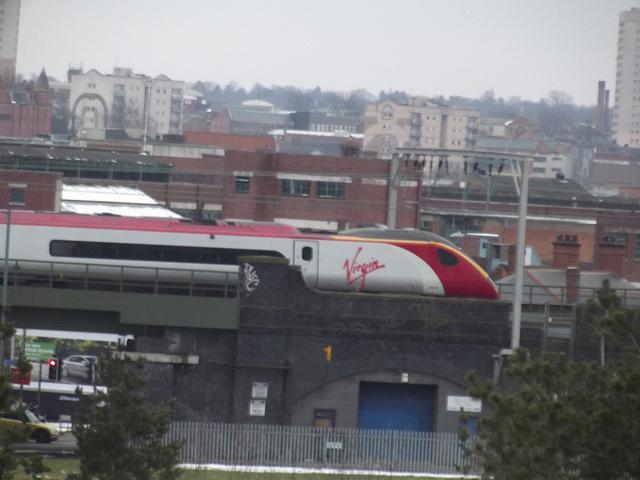The owners of this company first started it in which business?
Select the accurate answer and provide justification: `Answer: choice
Rationale: srationale.`
Options: Spaceship, record, phones, airline. Answer: record.
Rationale: Virgin was first a record company. 